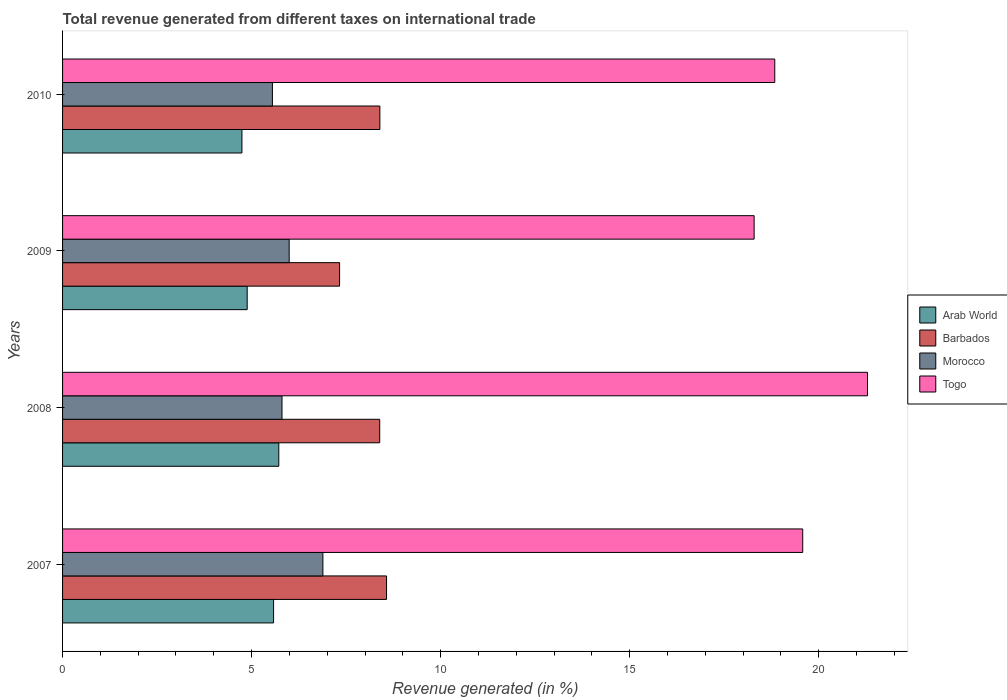How many different coloured bars are there?
Provide a succinct answer. 4. How many bars are there on the 4th tick from the top?
Provide a succinct answer. 4. What is the label of the 3rd group of bars from the top?
Your answer should be very brief. 2008. In how many cases, is the number of bars for a given year not equal to the number of legend labels?
Offer a very short reply. 0. What is the total revenue generated in Barbados in 2008?
Give a very brief answer. 8.39. Across all years, what is the maximum total revenue generated in Arab World?
Your response must be concise. 5.72. Across all years, what is the minimum total revenue generated in Barbados?
Give a very brief answer. 7.33. In which year was the total revenue generated in Barbados minimum?
Give a very brief answer. 2009. What is the total total revenue generated in Barbados in the graph?
Make the answer very short. 32.68. What is the difference between the total revenue generated in Arab World in 2007 and that in 2009?
Give a very brief answer. 0.7. What is the difference between the total revenue generated in Morocco in 2010 and the total revenue generated in Togo in 2009?
Make the answer very short. -12.74. What is the average total revenue generated in Arab World per year?
Keep it short and to the point. 5.23. In the year 2009, what is the difference between the total revenue generated in Arab World and total revenue generated in Togo?
Provide a succinct answer. -13.41. What is the ratio of the total revenue generated in Barbados in 2007 to that in 2008?
Your answer should be very brief. 1.02. Is the total revenue generated in Morocco in 2007 less than that in 2010?
Give a very brief answer. No. Is the difference between the total revenue generated in Arab World in 2007 and 2008 greater than the difference between the total revenue generated in Togo in 2007 and 2008?
Provide a short and direct response. Yes. What is the difference between the highest and the second highest total revenue generated in Togo?
Ensure brevity in your answer.  1.71. What is the difference between the highest and the lowest total revenue generated in Arab World?
Offer a very short reply. 0.98. In how many years, is the total revenue generated in Arab World greater than the average total revenue generated in Arab World taken over all years?
Keep it short and to the point. 2. Is it the case that in every year, the sum of the total revenue generated in Togo and total revenue generated in Barbados is greater than the sum of total revenue generated in Arab World and total revenue generated in Morocco?
Give a very brief answer. No. What does the 2nd bar from the top in 2007 represents?
Your answer should be compact. Morocco. What does the 2nd bar from the bottom in 2007 represents?
Your answer should be very brief. Barbados. Are all the bars in the graph horizontal?
Your response must be concise. Yes. Does the graph contain any zero values?
Make the answer very short. No. How many legend labels are there?
Provide a succinct answer. 4. How are the legend labels stacked?
Ensure brevity in your answer.  Vertical. What is the title of the graph?
Your response must be concise. Total revenue generated from different taxes on international trade. Does "Qatar" appear as one of the legend labels in the graph?
Give a very brief answer. No. What is the label or title of the X-axis?
Your answer should be very brief. Revenue generated (in %). What is the Revenue generated (in %) of Arab World in 2007?
Provide a short and direct response. 5.58. What is the Revenue generated (in %) of Barbados in 2007?
Your answer should be compact. 8.57. What is the Revenue generated (in %) in Morocco in 2007?
Offer a terse response. 6.89. What is the Revenue generated (in %) in Togo in 2007?
Make the answer very short. 19.58. What is the Revenue generated (in %) of Arab World in 2008?
Offer a terse response. 5.72. What is the Revenue generated (in %) in Barbados in 2008?
Your answer should be very brief. 8.39. What is the Revenue generated (in %) in Morocco in 2008?
Your response must be concise. 5.8. What is the Revenue generated (in %) in Togo in 2008?
Keep it short and to the point. 21.29. What is the Revenue generated (in %) in Arab World in 2009?
Your answer should be very brief. 4.88. What is the Revenue generated (in %) of Barbados in 2009?
Your response must be concise. 7.33. What is the Revenue generated (in %) of Morocco in 2009?
Your answer should be very brief. 5.99. What is the Revenue generated (in %) in Togo in 2009?
Make the answer very short. 18.29. What is the Revenue generated (in %) in Arab World in 2010?
Your response must be concise. 4.74. What is the Revenue generated (in %) in Barbados in 2010?
Give a very brief answer. 8.39. What is the Revenue generated (in %) of Morocco in 2010?
Make the answer very short. 5.55. What is the Revenue generated (in %) in Togo in 2010?
Provide a succinct answer. 18.84. Across all years, what is the maximum Revenue generated (in %) of Arab World?
Make the answer very short. 5.72. Across all years, what is the maximum Revenue generated (in %) of Barbados?
Provide a short and direct response. 8.57. Across all years, what is the maximum Revenue generated (in %) of Morocco?
Your response must be concise. 6.89. Across all years, what is the maximum Revenue generated (in %) in Togo?
Your response must be concise. 21.29. Across all years, what is the minimum Revenue generated (in %) of Arab World?
Ensure brevity in your answer.  4.74. Across all years, what is the minimum Revenue generated (in %) of Barbados?
Offer a very short reply. 7.33. Across all years, what is the minimum Revenue generated (in %) in Morocco?
Ensure brevity in your answer.  5.55. Across all years, what is the minimum Revenue generated (in %) in Togo?
Give a very brief answer. 18.29. What is the total Revenue generated (in %) of Arab World in the graph?
Give a very brief answer. 20.93. What is the total Revenue generated (in %) in Barbados in the graph?
Offer a very short reply. 32.68. What is the total Revenue generated (in %) in Morocco in the graph?
Ensure brevity in your answer.  24.24. What is the total Revenue generated (in %) in Togo in the graph?
Offer a very short reply. 78. What is the difference between the Revenue generated (in %) in Arab World in 2007 and that in 2008?
Provide a succinct answer. -0.14. What is the difference between the Revenue generated (in %) of Barbados in 2007 and that in 2008?
Offer a very short reply. 0.18. What is the difference between the Revenue generated (in %) of Morocco in 2007 and that in 2008?
Offer a terse response. 1.08. What is the difference between the Revenue generated (in %) of Togo in 2007 and that in 2008?
Your response must be concise. -1.71. What is the difference between the Revenue generated (in %) in Arab World in 2007 and that in 2009?
Make the answer very short. 0.7. What is the difference between the Revenue generated (in %) in Barbados in 2007 and that in 2009?
Offer a terse response. 1.24. What is the difference between the Revenue generated (in %) in Morocco in 2007 and that in 2009?
Your answer should be compact. 0.89. What is the difference between the Revenue generated (in %) of Togo in 2007 and that in 2009?
Offer a very short reply. 1.29. What is the difference between the Revenue generated (in %) of Arab World in 2007 and that in 2010?
Give a very brief answer. 0.84. What is the difference between the Revenue generated (in %) in Barbados in 2007 and that in 2010?
Your response must be concise. 0.18. What is the difference between the Revenue generated (in %) in Morocco in 2007 and that in 2010?
Provide a short and direct response. 1.34. What is the difference between the Revenue generated (in %) of Togo in 2007 and that in 2010?
Give a very brief answer. 0.74. What is the difference between the Revenue generated (in %) in Arab World in 2008 and that in 2009?
Provide a short and direct response. 0.84. What is the difference between the Revenue generated (in %) in Barbados in 2008 and that in 2009?
Provide a succinct answer. 1.06. What is the difference between the Revenue generated (in %) in Morocco in 2008 and that in 2009?
Keep it short and to the point. -0.19. What is the difference between the Revenue generated (in %) in Togo in 2008 and that in 2009?
Offer a very short reply. 3. What is the difference between the Revenue generated (in %) in Barbados in 2008 and that in 2010?
Provide a succinct answer. -0. What is the difference between the Revenue generated (in %) in Morocco in 2008 and that in 2010?
Provide a succinct answer. 0.25. What is the difference between the Revenue generated (in %) in Togo in 2008 and that in 2010?
Provide a short and direct response. 2.45. What is the difference between the Revenue generated (in %) in Arab World in 2009 and that in 2010?
Ensure brevity in your answer.  0.14. What is the difference between the Revenue generated (in %) of Barbados in 2009 and that in 2010?
Your answer should be very brief. -1.06. What is the difference between the Revenue generated (in %) in Morocco in 2009 and that in 2010?
Offer a very short reply. 0.44. What is the difference between the Revenue generated (in %) of Togo in 2009 and that in 2010?
Provide a short and direct response. -0.55. What is the difference between the Revenue generated (in %) of Arab World in 2007 and the Revenue generated (in %) of Barbados in 2008?
Offer a terse response. -2.81. What is the difference between the Revenue generated (in %) of Arab World in 2007 and the Revenue generated (in %) of Morocco in 2008?
Make the answer very short. -0.22. What is the difference between the Revenue generated (in %) in Arab World in 2007 and the Revenue generated (in %) in Togo in 2008?
Your answer should be very brief. -15.71. What is the difference between the Revenue generated (in %) in Barbados in 2007 and the Revenue generated (in %) in Morocco in 2008?
Ensure brevity in your answer.  2.77. What is the difference between the Revenue generated (in %) of Barbados in 2007 and the Revenue generated (in %) of Togo in 2008?
Provide a short and direct response. -12.72. What is the difference between the Revenue generated (in %) of Morocco in 2007 and the Revenue generated (in %) of Togo in 2008?
Your response must be concise. -14.41. What is the difference between the Revenue generated (in %) of Arab World in 2007 and the Revenue generated (in %) of Barbados in 2009?
Your answer should be very brief. -1.75. What is the difference between the Revenue generated (in %) of Arab World in 2007 and the Revenue generated (in %) of Morocco in 2009?
Your answer should be very brief. -0.41. What is the difference between the Revenue generated (in %) of Arab World in 2007 and the Revenue generated (in %) of Togo in 2009?
Make the answer very short. -12.71. What is the difference between the Revenue generated (in %) of Barbados in 2007 and the Revenue generated (in %) of Morocco in 2009?
Provide a short and direct response. 2.58. What is the difference between the Revenue generated (in %) in Barbados in 2007 and the Revenue generated (in %) in Togo in 2009?
Offer a terse response. -9.72. What is the difference between the Revenue generated (in %) in Morocco in 2007 and the Revenue generated (in %) in Togo in 2009?
Keep it short and to the point. -11.41. What is the difference between the Revenue generated (in %) in Arab World in 2007 and the Revenue generated (in %) in Barbados in 2010?
Your response must be concise. -2.81. What is the difference between the Revenue generated (in %) of Arab World in 2007 and the Revenue generated (in %) of Morocco in 2010?
Your answer should be compact. 0.03. What is the difference between the Revenue generated (in %) of Arab World in 2007 and the Revenue generated (in %) of Togo in 2010?
Offer a terse response. -13.26. What is the difference between the Revenue generated (in %) in Barbados in 2007 and the Revenue generated (in %) in Morocco in 2010?
Offer a terse response. 3.02. What is the difference between the Revenue generated (in %) in Barbados in 2007 and the Revenue generated (in %) in Togo in 2010?
Provide a short and direct response. -10.27. What is the difference between the Revenue generated (in %) in Morocco in 2007 and the Revenue generated (in %) in Togo in 2010?
Make the answer very short. -11.95. What is the difference between the Revenue generated (in %) of Arab World in 2008 and the Revenue generated (in %) of Barbados in 2009?
Keep it short and to the point. -1.61. What is the difference between the Revenue generated (in %) of Arab World in 2008 and the Revenue generated (in %) of Morocco in 2009?
Your answer should be compact. -0.27. What is the difference between the Revenue generated (in %) of Arab World in 2008 and the Revenue generated (in %) of Togo in 2009?
Provide a succinct answer. -12.57. What is the difference between the Revenue generated (in %) of Barbados in 2008 and the Revenue generated (in %) of Morocco in 2009?
Offer a terse response. 2.39. What is the difference between the Revenue generated (in %) of Barbados in 2008 and the Revenue generated (in %) of Togo in 2009?
Keep it short and to the point. -9.9. What is the difference between the Revenue generated (in %) in Morocco in 2008 and the Revenue generated (in %) in Togo in 2009?
Your response must be concise. -12.49. What is the difference between the Revenue generated (in %) of Arab World in 2008 and the Revenue generated (in %) of Barbados in 2010?
Offer a terse response. -2.67. What is the difference between the Revenue generated (in %) in Arab World in 2008 and the Revenue generated (in %) in Morocco in 2010?
Your answer should be compact. 0.17. What is the difference between the Revenue generated (in %) in Arab World in 2008 and the Revenue generated (in %) in Togo in 2010?
Provide a short and direct response. -13.12. What is the difference between the Revenue generated (in %) of Barbados in 2008 and the Revenue generated (in %) of Morocco in 2010?
Your answer should be very brief. 2.84. What is the difference between the Revenue generated (in %) in Barbados in 2008 and the Revenue generated (in %) in Togo in 2010?
Offer a terse response. -10.45. What is the difference between the Revenue generated (in %) of Morocco in 2008 and the Revenue generated (in %) of Togo in 2010?
Offer a very short reply. -13.03. What is the difference between the Revenue generated (in %) of Arab World in 2009 and the Revenue generated (in %) of Barbados in 2010?
Offer a terse response. -3.51. What is the difference between the Revenue generated (in %) in Arab World in 2009 and the Revenue generated (in %) in Morocco in 2010?
Give a very brief answer. -0.67. What is the difference between the Revenue generated (in %) of Arab World in 2009 and the Revenue generated (in %) of Togo in 2010?
Provide a short and direct response. -13.96. What is the difference between the Revenue generated (in %) in Barbados in 2009 and the Revenue generated (in %) in Morocco in 2010?
Make the answer very short. 1.78. What is the difference between the Revenue generated (in %) of Barbados in 2009 and the Revenue generated (in %) of Togo in 2010?
Keep it short and to the point. -11.51. What is the difference between the Revenue generated (in %) in Morocco in 2009 and the Revenue generated (in %) in Togo in 2010?
Make the answer very short. -12.84. What is the average Revenue generated (in %) of Arab World per year?
Keep it short and to the point. 5.23. What is the average Revenue generated (in %) in Barbados per year?
Give a very brief answer. 8.17. What is the average Revenue generated (in %) in Morocco per year?
Make the answer very short. 6.06. What is the average Revenue generated (in %) of Togo per year?
Your answer should be compact. 19.5. In the year 2007, what is the difference between the Revenue generated (in %) in Arab World and Revenue generated (in %) in Barbados?
Provide a succinct answer. -2.99. In the year 2007, what is the difference between the Revenue generated (in %) in Arab World and Revenue generated (in %) in Morocco?
Make the answer very short. -1.3. In the year 2007, what is the difference between the Revenue generated (in %) of Arab World and Revenue generated (in %) of Togo?
Your answer should be compact. -14. In the year 2007, what is the difference between the Revenue generated (in %) in Barbados and Revenue generated (in %) in Morocco?
Make the answer very short. 1.68. In the year 2007, what is the difference between the Revenue generated (in %) in Barbados and Revenue generated (in %) in Togo?
Make the answer very short. -11.01. In the year 2007, what is the difference between the Revenue generated (in %) of Morocco and Revenue generated (in %) of Togo?
Offer a very short reply. -12.69. In the year 2008, what is the difference between the Revenue generated (in %) of Arab World and Revenue generated (in %) of Barbados?
Provide a succinct answer. -2.67. In the year 2008, what is the difference between the Revenue generated (in %) of Arab World and Revenue generated (in %) of Morocco?
Give a very brief answer. -0.09. In the year 2008, what is the difference between the Revenue generated (in %) of Arab World and Revenue generated (in %) of Togo?
Give a very brief answer. -15.57. In the year 2008, what is the difference between the Revenue generated (in %) in Barbados and Revenue generated (in %) in Morocco?
Your answer should be compact. 2.58. In the year 2008, what is the difference between the Revenue generated (in %) in Barbados and Revenue generated (in %) in Togo?
Make the answer very short. -12.9. In the year 2008, what is the difference between the Revenue generated (in %) in Morocco and Revenue generated (in %) in Togo?
Your answer should be very brief. -15.49. In the year 2009, what is the difference between the Revenue generated (in %) of Arab World and Revenue generated (in %) of Barbados?
Your answer should be compact. -2.44. In the year 2009, what is the difference between the Revenue generated (in %) in Arab World and Revenue generated (in %) in Morocco?
Ensure brevity in your answer.  -1.11. In the year 2009, what is the difference between the Revenue generated (in %) in Arab World and Revenue generated (in %) in Togo?
Offer a terse response. -13.41. In the year 2009, what is the difference between the Revenue generated (in %) in Barbados and Revenue generated (in %) in Morocco?
Your answer should be very brief. 1.33. In the year 2009, what is the difference between the Revenue generated (in %) in Barbados and Revenue generated (in %) in Togo?
Your answer should be compact. -10.96. In the year 2009, what is the difference between the Revenue generated (in %) in Morocco and Revenue generated (in %) in Togo?
Keep it short and to the point. -12.3. In the year 2010, what is the difference between the Revenue generated (in %) in Arab World and Revenue generated (in %) in Barbados?
Offer a terse response. -3.65. In the year 2010, what is the difference between the Revenue generated (in %) of Arab World and Revenue generated (in %) of Morocco?
Offer a terse response. -0.81. In the year 2010, what is the difference between the Revenue generated (in %) of Arab World and Revenue generated (in %) of Togo?
Give a very brief answer. -14.09. In the year 2010, what is the difference between the Revenue generated (in %) in Barbados and Revenue generated (in %) in Morocco?
Keep it short and to the point. 2.84. In the year 2010, what is the difference between the Revenue generated (in %) of Barbados and Revenue generated (in %) of Togo?
Keep it short and to the point. -10.45. In the year 2010, what is the difference between the Revenue generated (in %) of Morocco and Revenue generated (in %) of Togo?
Make the answer very short. -13.29. What is the ratio of the Revenue generated (in %) of Arab World in 2007 to that in 2008?
Offer a terse response. 0.98. What is the ratio of the Revenue generated (in %) in Barbados in 2007 to that in 2008?
Ensure brevity in your answer.  1.02. What is the ratio of the Revenue generated (in %) of Morocco in 2007 to that in 2008?
Give a very brief answer. 1.19. What is the ratio of the Revenue generated (in %) in Togo in 2007 to that in 2008?
Your answer should be very brief. 0.92. What is the ratio of the Revenue generated (in %) of Arab World in 2007 to that in 2009?
Offer a terse response. 1.14. What is the ratio of the Revenue generated (in %) in Barbados in 2007 to that in 2009?
Give a very brief answer. 1.17. What is the ratio of the Revenue generated (in %) of Morocco in 2007 to that in 2009?
Your answer should be very brief. 1.15. What is the ratio of the Revenue generated (in %) of Togo in 2007 to that in 2009?
Ensure brevity in your answer.  1.07. What is the ratio of the Revenue generated (in %) in Arab World in 2007 to that in 2010?
Offer a very short reply. 1.18. What is the ratio of the Revenue generated (in %) of Barbados in 2007 to that in 2010?
Provide a succinct answer. 1.02. What is the ratio of the Revenue generated (in %) of Morocco in 2007 to that in 2010?
Provide a short and direct response. 1.24. What is the ratio of the Revenue generated (in %) of Togo in 2007 to that in 2010?
Provide a succinct answer. 1.04. What is the ratio of the Revenue generated (in %) of Arab World in 2008 to that in 2009?
Your response must be concise. 1.17. What is the ratio of the Revenue generated (in %) of Barbados in 2008 to that in 2009?
Make the answer very short. 1.14. What is the ratio of the Revenue generated (in %) of Morocco in 2008 to that in 2009?
Offer a very short reply. 0.97. What is the ratio of the Revenue generated (in %) in Togo in 2008 to that in 2009?
Offer a very short reply. 1.16. What is the ratio of the Revenue generated (in %) in Arab World in 2008 to that in 2010?
Offer a very short reply. 1.21. What is the ratio of the Revenue generated (in %) in Barbados in 2008 to that in 2010?
Offer a very short reply. 1. What is the ratio of the Revenue generated (in %) of Morocco in 2008 to that in 2010?
Offer a very short reply. 1.05. What is the ratio of the Revenue generated (in %) of Togo in 2008 to that in 2010?
Make the answer very short. 1.13. What is the ratio of the Revenue generated (in %) in Arab World in 2009 to that in 2010?
Your response must be concise. 1.03. What is the ratio of the Revenue generated (in %) of Barbados in 2009 to that in 2010?
Your answer should be very brief. 0.87. What is the ratio of the Revenue generated (in %) in Morocco in 2009 to that in 2010?
Offer a terse response. 1.08. What is the ratio of the Revenue generated (in %) of Togo in 2009 to that in 2010?
Your answer should be compact. 0.97. What is the difference between the highest and the second highest Revenue generated (in %) of Arab World?
Your answer should be very brief. 0.14. What is the difference between the highest and the second highest Revenue generated (in %) of Barbados?
Provide a short and direct response. 0.18. What is the difference between the highest and the second highest Revenue generated (in %) of Morocco?
Offer a terse response. 0.89. What is the difference between the highest and the second highest Revenue generated (in %) of Togo?
Your answer should be compact. 1.71. What is the difference between the highest and the lowest Revenue generated (in %) in Barbados?
Your answer should be very brief. 1.24. What is the difference between the highest and the lowest Revenue generated (in %) of Morocco?
Provide a succinct answer. 1.34. What is the difference between the highest and the lowest Revenue generated (in %) of Togo?
Ensure brevity in your answer.  3. 